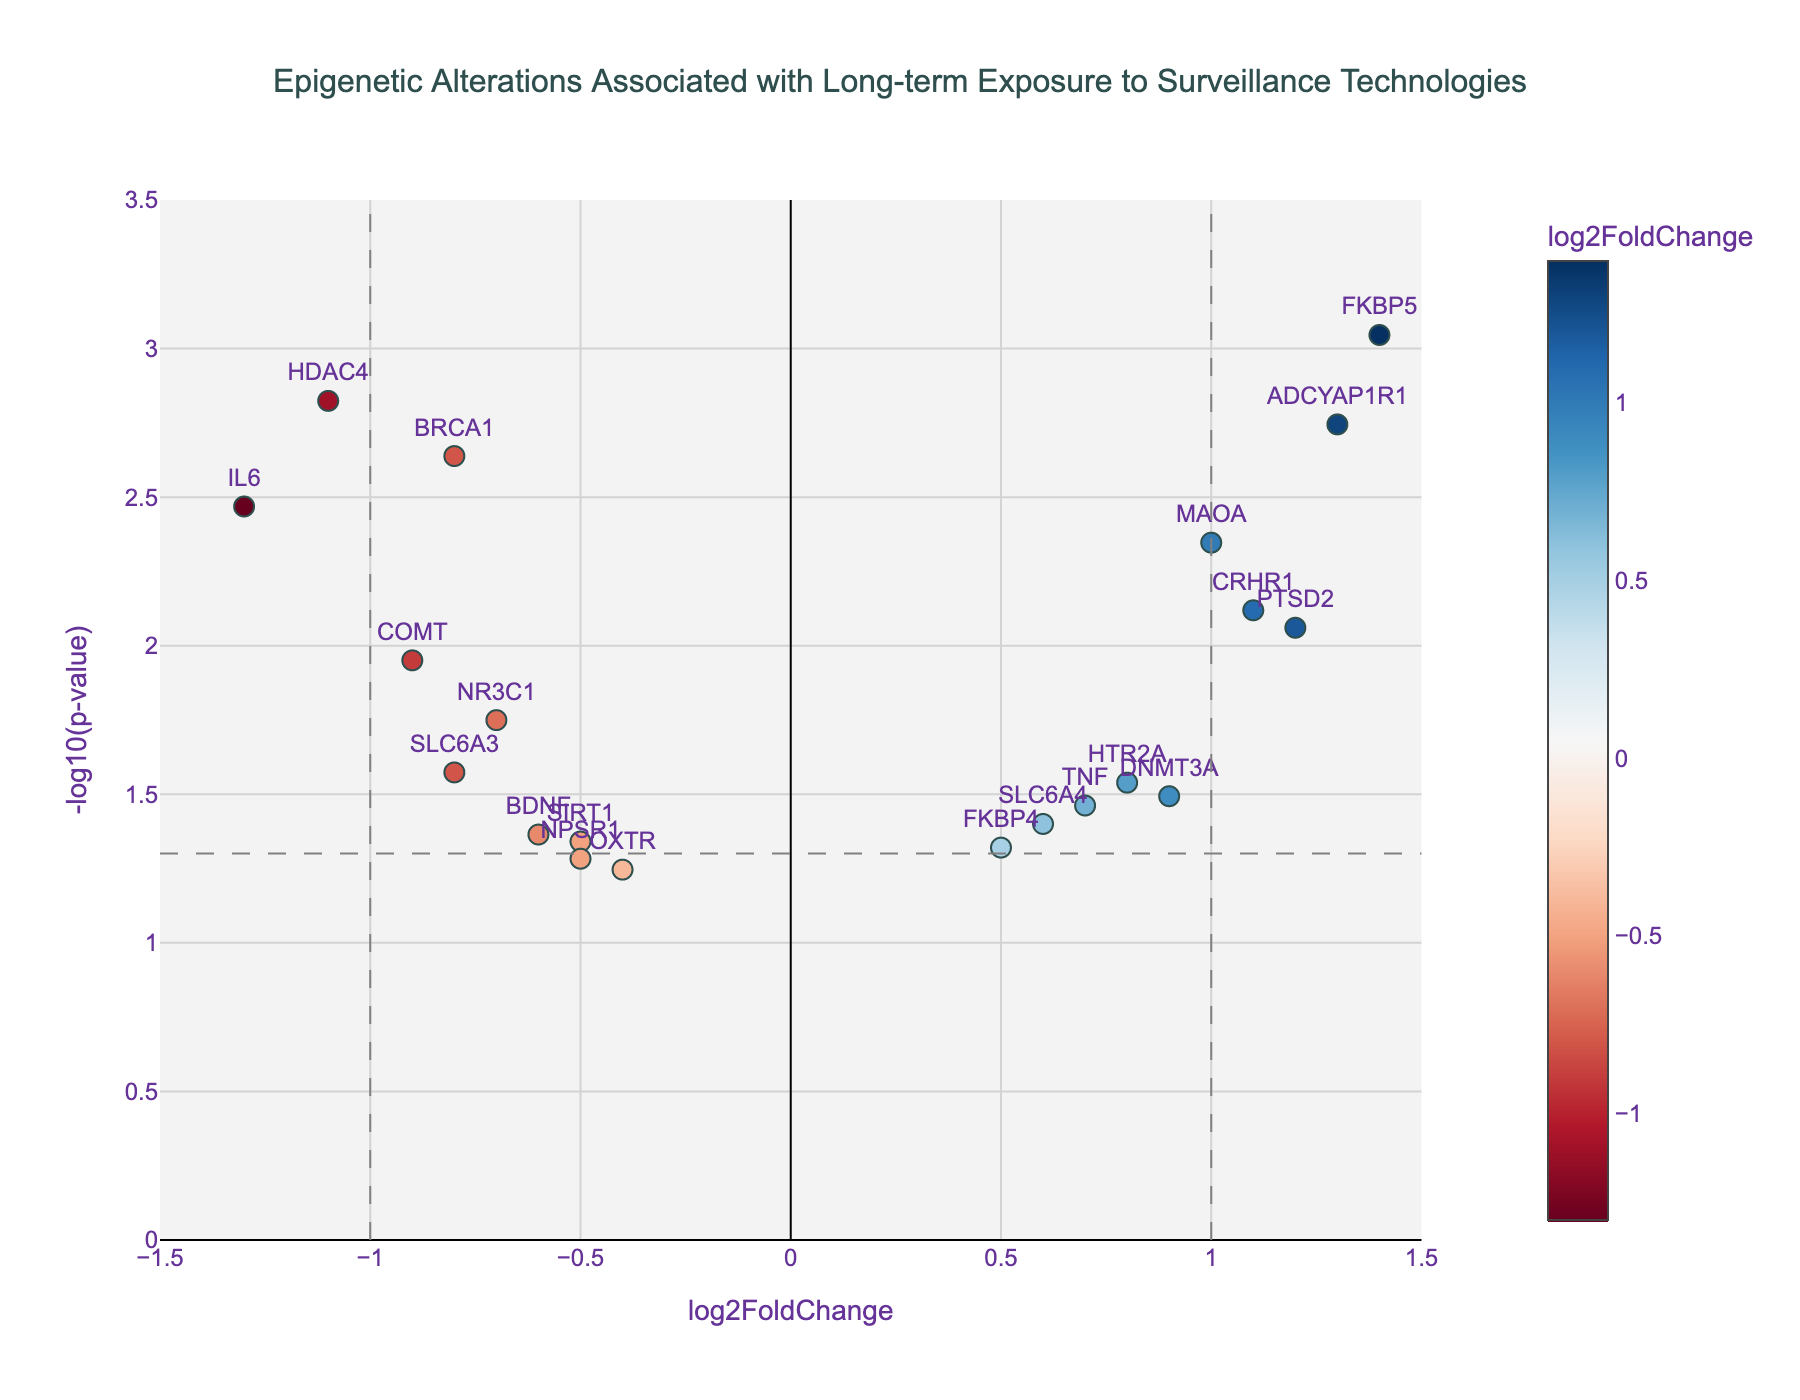How many genes have a log2FoldChange greater than 1? Look at the x-axis and count the number of data points (genes) that are positioned to the right of x = 1.
Answer: 4 Which gene has the lowest p-value? Check the y-axis for the highest -log10(p-value) value and identify the corresponding gene.
Answer: FKBP5 What is the relationship between log2FoldChange and p-value for the gene BRCA1? Find the data point labeled "BRCA1" and note its log2FoldChange and -log10(p-value) values. BRCA1 has a log2FoldChange of approximately -0.8 and a -log10(p-value) slightly above 2. Convert the -log10(p-value) back to p-value to determine the relationship.
Answer: log2FC: -0.8, p-value: 0.0023 Which gene has the highest log2FoldChange? Observe the x-axis for the data point farthest to the right and check the corresponding gene.
Answer: FKBP5 How many genes have statistically significant results (p < 0.05) and a log2FoldChange greater than 0? Focus on genes above the horizontal line at y = -log10(0.05) and with positive log2FoldChange values (right of x = 0). Count these genes.
Answer: 6 Compare the log2FoldChange of HDAC4 and IL6. Which one is more downregulated? Identify the data points for HDAC4 and IL6, and compare their log2FoldChange values. The more negative the value, the greater the downregulation. HDAC4 has a log2FoldChange of -1.1 while IL6 has -1.3; thus, IL6 is more downregulated.
Answer: IL6 What is the common property of genes that are further from the center horizontally? Analyze the data points farthest from the center horizontally (both left and right) to determine their log2FoldChange values. These genes have extreme log2FoldChange values, indicating either strong upregulation or downregulation.
Answer: Extreme log2FoldChange How many genes exhibit non-significant p-values (p > 0.05)? Look below the horizontal line at y = -log10(0.05) and count the data points.
Answer: 3 